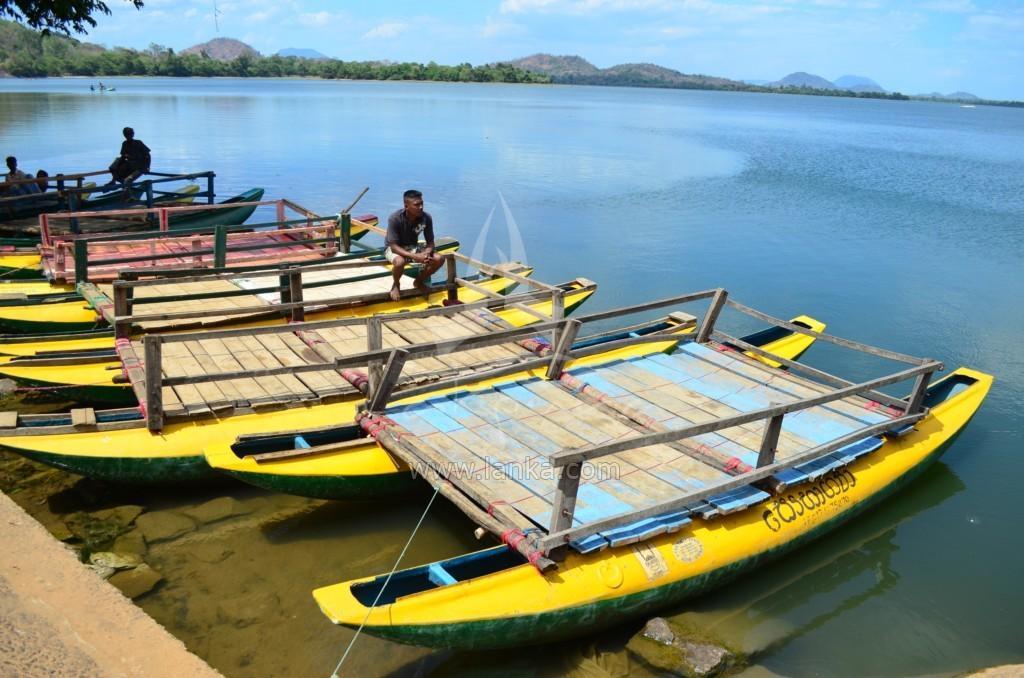Could you give a brief overview of what you see in this image? In this picture we can see few boats on the water and few people are seated in the boats, in the background we can find few trees and hills. 